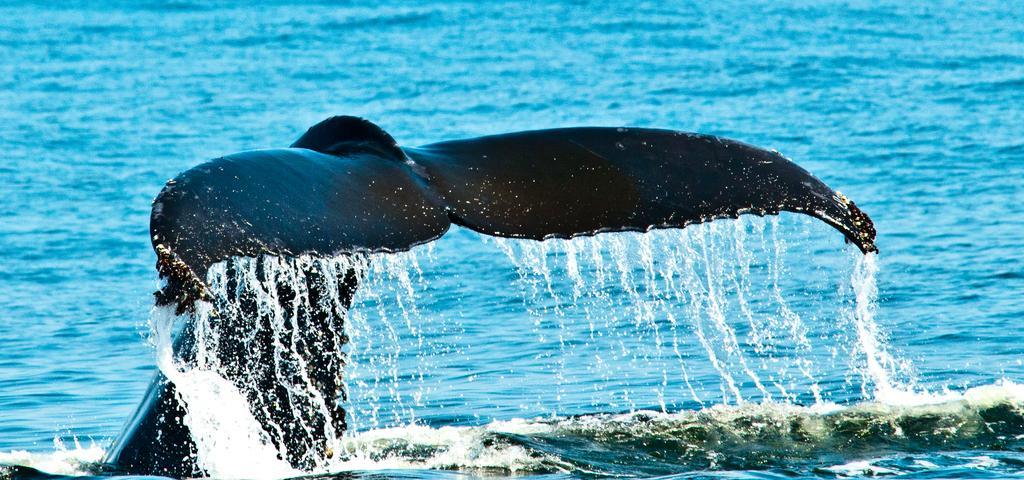Can you describe this image briefly? In this image we can see a whale in the water. 